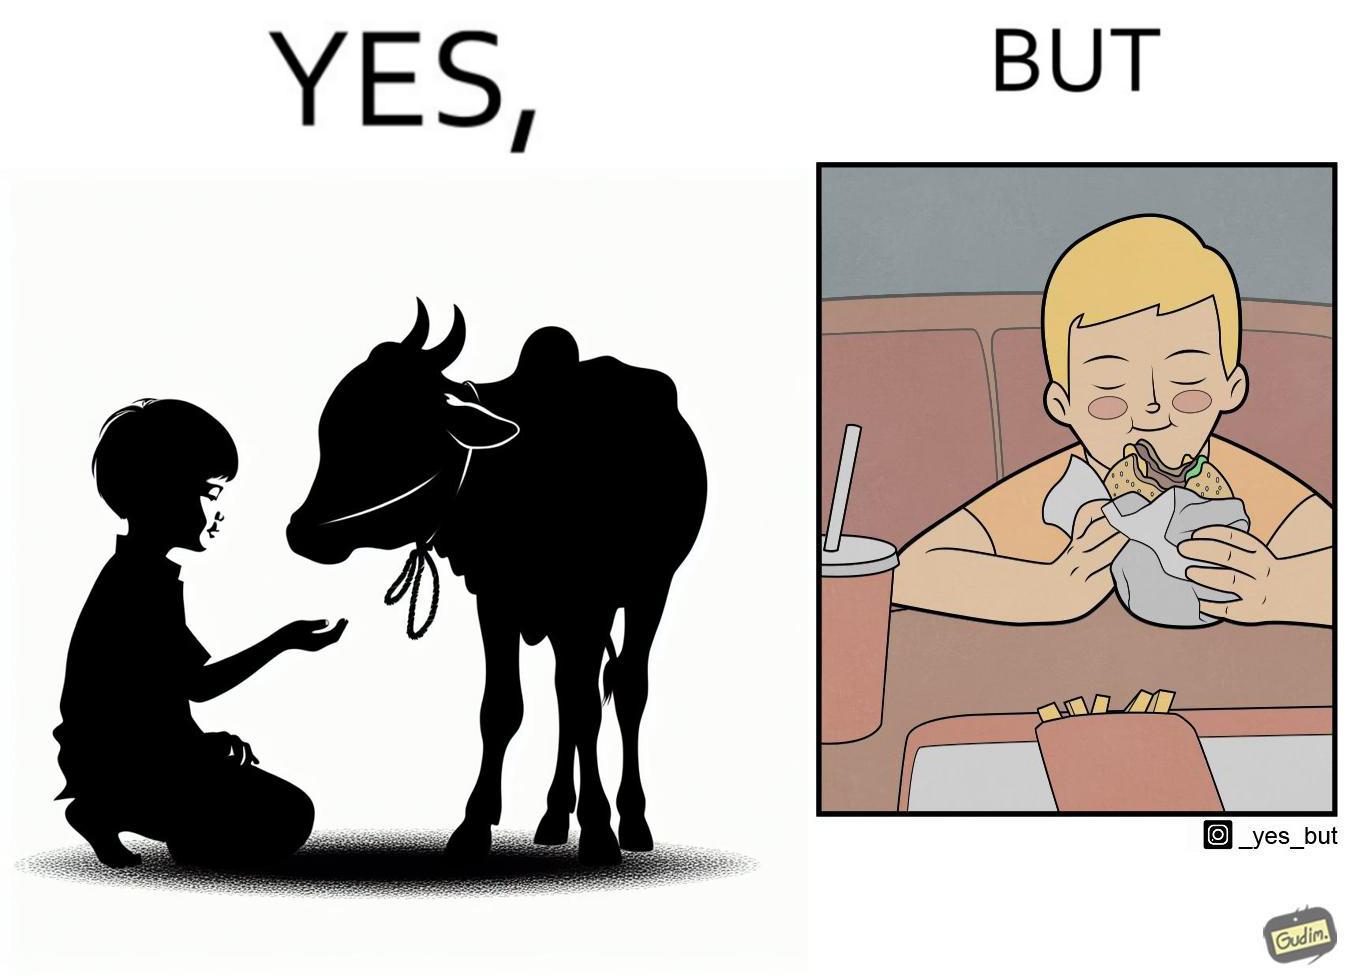What is shown in the left half versus the right half of this image? In the left part of the image: A boy petting a cow In the right part of the image: A boy eating a hamburger 